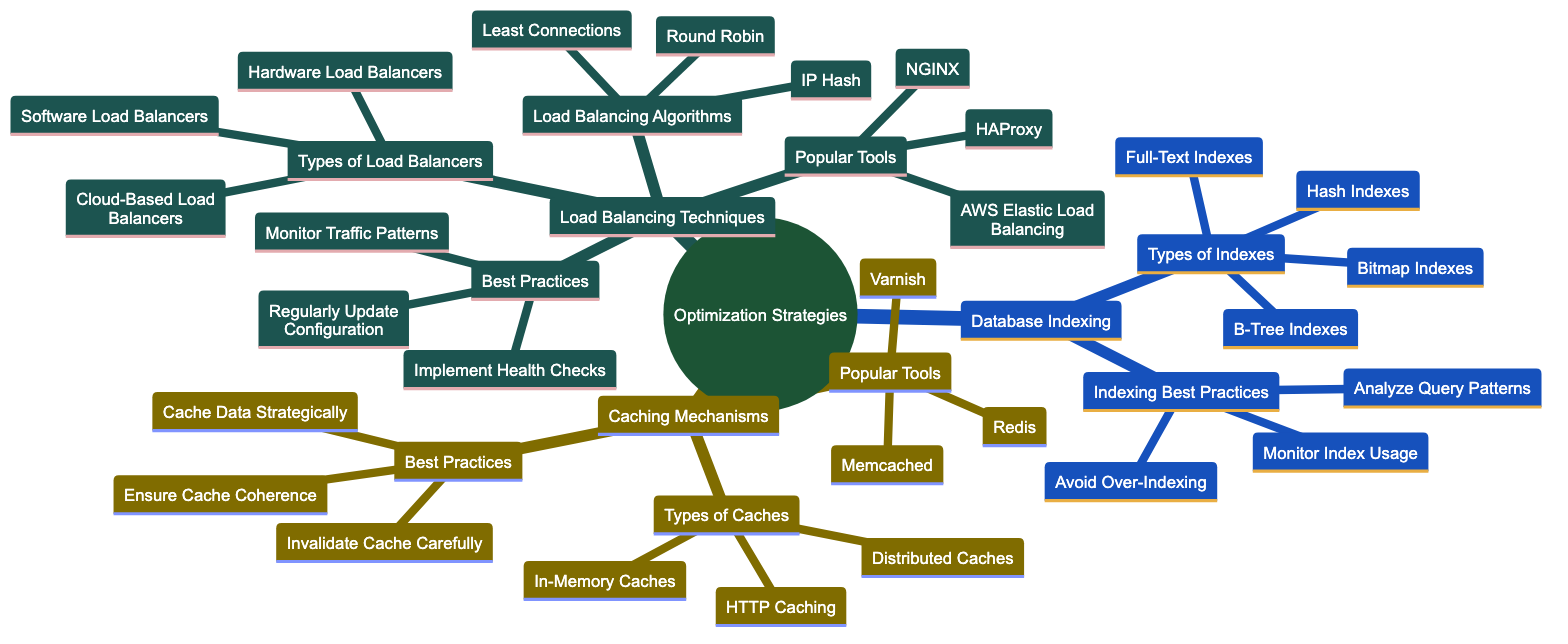What are the types of indexes listed under Database Indexing? The diagram displays four types of indexes as part of the Database Indexing section: B-Tree Indexes, Hash Indexes, Bitmap Indexes, and Full-Text Indexes.
Answer: B-Tree Indexes, Hash Indexes, Bitmap Indexes, Full-Text Indexes How many types of caches are mentioned? Under the Caching Mechanisms section, three types of caches are identified: In-Memory Caches, Distributed Caches, and HTTP Caching, which totals three types.
Answer: 3 What are the best practices for indexing? The diagram indicates three best practices related to indexing: Analyze Query Patterns, Monitor Index Usage, and Avoid Over-Indexing, which are directly listed under the Indexing Best Practices node.
Answer: Analyze Query Patterns, Monitor Index Usage, Avoid Over-Indexing Which caching tool is listed first in the Popular Tools for caching? The diagram lists Redis as the first caching tool under the Popular Tools section of Caching Mechanisms, making it the first mentioned.
Answer: Redis What is the first type of load balancer mentioned in the Types of Load Balancers? In the Load Balancing Techniques section, the first type of load balancer is identified as Hardware Load Balancers, as indicated by its position in the list.
Answer: Hardware Load Balancers What load balancing algorithm comes after Round Robin? The diagram shows that the load balancing algorithm that follows Round Robin in the list is Least Connections, indicating the sequence of algorithms.
Answer: Least Connections How many popular tools are listed under Load Balancing Techniques? The diagram provides a list of three popular tools under Load Balancing Techniques: NGINX, HAProxy, and AWS Elastic Load Balancing, indicating a total of three tools.
Answer: 3 What is the last best practice listed under Load Balancing Techniques? The last best practice noted under the Load Balancing Techniques section is Implement Health Checks, as seen at the end of the best practices list.
Answer: Implement Health Checks What are two types of caching mentioned in the diagram? The diagram cites three types of caches, and two of them are In-Memory Caches and Distributed Caches, chosen from the Types of Caches node.
Answer: In-Memory Caches, Distributed Caches 